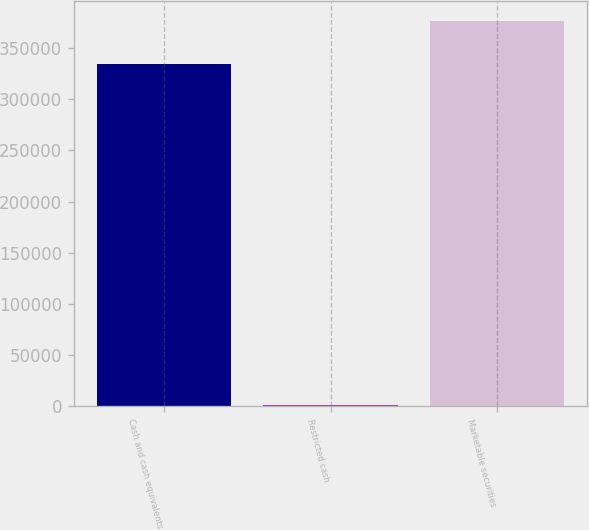Convert chart to OTSL. <chart><loc_0><loc_0><loc_500><loc_500><bar_chart><fcel>Cash and cash equivalents<fcel>Restricted cash<fcel>Marketable securities<nl><fcel>334352<fcel>1356<fcel>376723<nl></chart> 